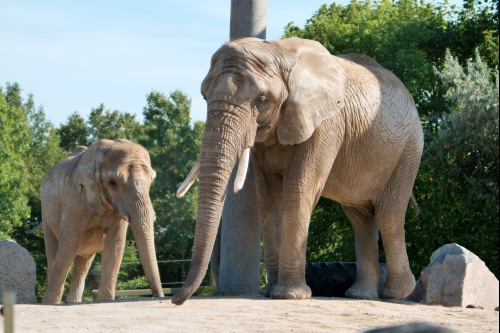Describe the objects in this image and their specific colors. I can see elephant in lightblue, gray, maroon, black, and darkgray tones and elephant in lightblue, gray, and tan tones in this image. 